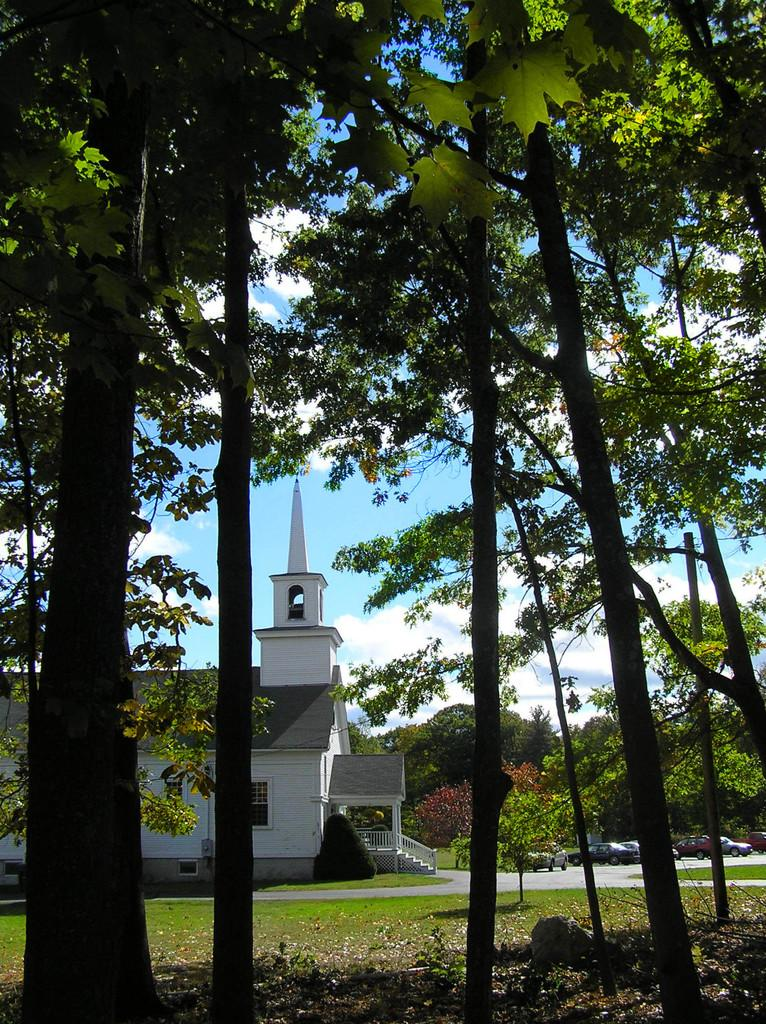What type of vegetation can be seen in the image? There are trees and grass in the image. What is the natural element present on the ground in the image? There is a rock in the image. What type of man-made structures can be seen in the image? There is a house in the image. What is visible on the road in the image? There are vehicles on the road in the image. What can be seen in the background of the image? The sky is visible in the background of the image. What type of music can be heard coming from the house in the image? There is no indication of music or any sounds in the image, so it's not possible to determine what, if any, music might be heard. 